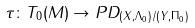Convert formula to latex. <formula><loc_0><loc_0><loc_500><loc_500>\tau \colon T _ { 0 } ( M ) \to P D _ { ( X , \Lambda _ { 0 } ) / ( Y , \Pi _ { 0 } ) }</formula> 